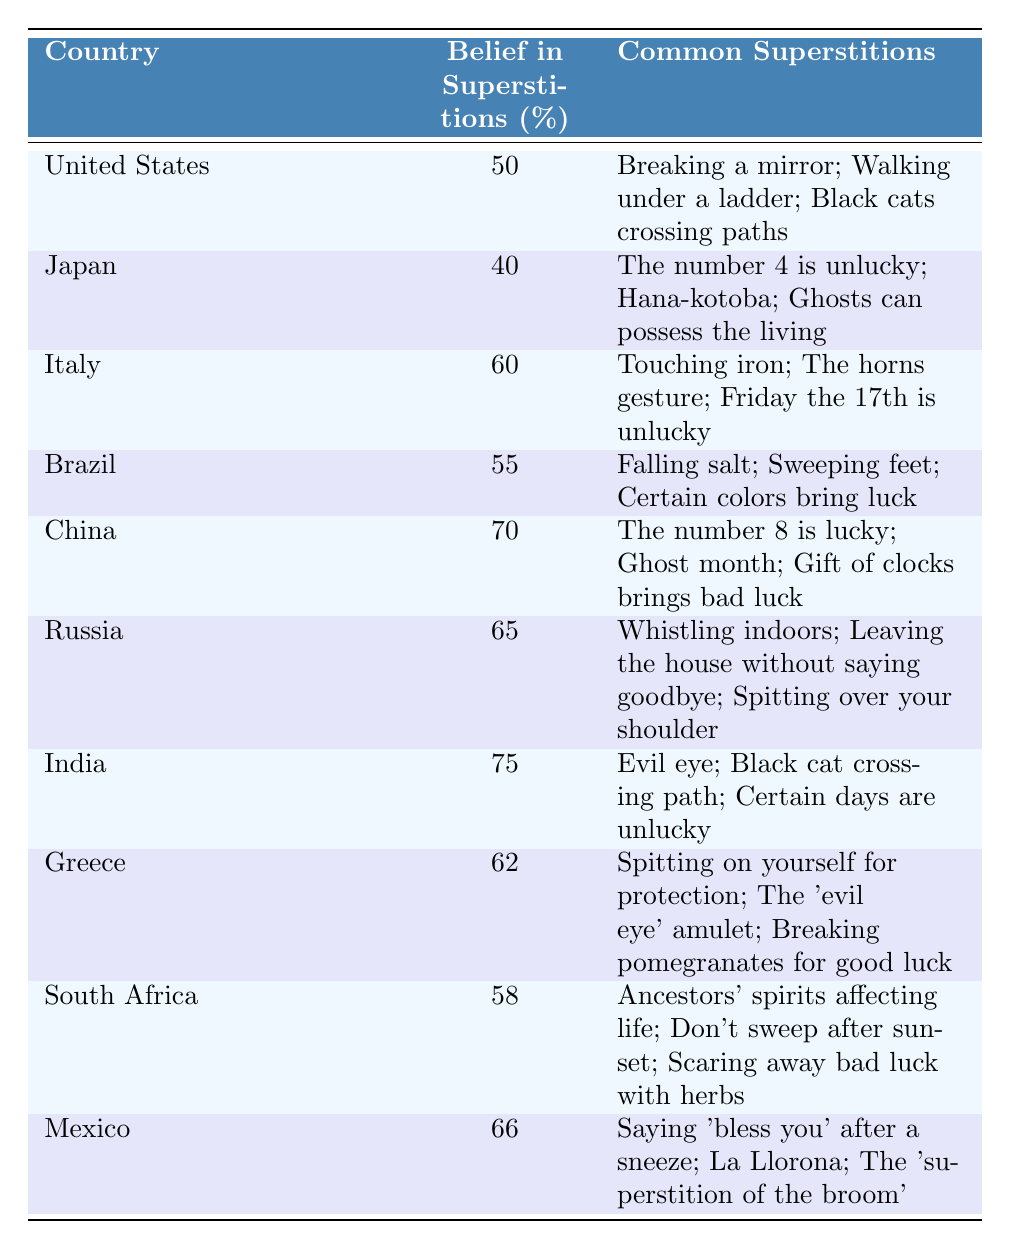What country has the highest belief in superstitions? The table lists the "Belief in Superstitions (%)" for each country. India has the highest percentage at 75%.
Answer: India What are the common superstitions reported by China? The table provides a list of common superstitions for China: "The number 8 is lucky", "Ghost month", and "Gift of clocks brings bad luck".
Answer: The number 8 is lucky; Ghost month; Gift of clocks brings bad luck Is the belief in superstitions higher in Brazil than in Japan? Brazil has a belief percentage of 55%, while Japan has 40%. Since 55% is greater than 40%, the belief in superstitions is indeed higher in Brazil.
Answer: Yes Which country shows a belief in superstitions of 62%? According to the table, Greece has a belief percentage of 62%.
Answer: Greece What is the average percentage of belief in superstitions for the countries listed? The percentages are: 50, 40, 60, 55, 70, 65, 75, 62, 58, and 66. Adding these gives a total of  62% (620/10).
Answer: 62% Is there a country where the belief in superstitions exceeds 65%? From the table, we can see that India (75%), China (70%), and Russia (65%) all have percentages above 65%.
Answer: Yes Which country has the lowest reported belief in superstitions among the listed countries? The lowest percentage is found in Japan, with 40% belief in superstitions.
Answer: Japan If we consider the common superstitions reported for Italy, what is one superstition related to luck? One of Italy's superstitions listed is "Friday the 17th is unlucky", which relates to luck.
Answer: Friday the 17th is unlucky How many countries report a belief in superstitions of more than 60%? The countries with more than 60% belief are Italy (60%), Brazil (55%), China (70%), Russia (65%), India (75%), Greece (62%), and Mexico (66%). That totals 7 countries.
Answer: 7 Is belief in superstitions correlated with any specific country in terms of common superstitions? Each country has its unique superstitions, but India and the United States both mention cats (with reference to black cats). This suggests cultural overlaps.
Answer: Yes 